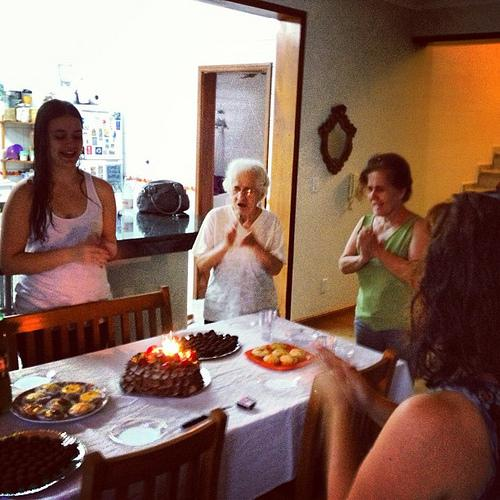Identify and describe any accessories or objects placed on the table or island. A grey purse is sitting on the island and a brass mirror is affixed to the wall. Describe the tablecloth as mentioned in the captions. The tablecloth is white in color. What kind of fabric is the tank top made of, and what color is it? The fabric type is not specified, but the tank top is white in color. Identify the color and shape of the plate full of food described in the caption. The plate is orange, square in shape and full of food. What different types of plates with food are mentioned, and what materials are they made of? An orange square plate, a round silver plate, and a round plastic plate, all with food on them. What kind of celebratory event do the people in the image seem to be participating in? The people are celebrating a birthday. What type of light is in the background of the image? There is a light in the background, but the type is not specified. Provide a detailed description of the older woman standing near the table. The older woman is standing near the table, wearing glasses, clapping and has white hair. Who is the subject mentioned as wearing a pair of glasses? An elderly woman is mentioned as wearing glasses. Count and describe the number of chairs mentioned in the image. There are two chairs mentioned, both wooden and brown in color. 